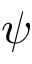<formula> <loc_0><loc_0><loc_500><loc_500>\psi</formula> 